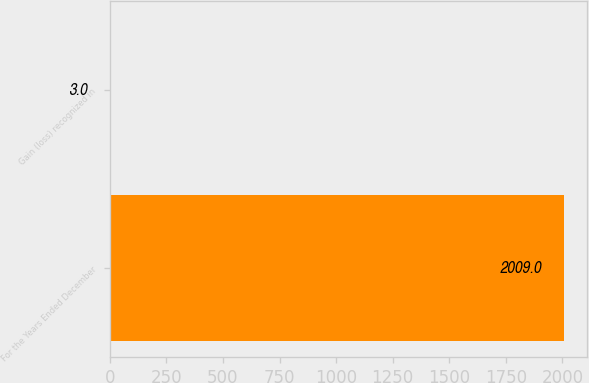Convert chart. <chart><loc_0><loc_0><loc_500><loc_500><bar_chart><fcel>For the Years Ended December<fcel>Gain (loss) recognized in<nl><fcel>2009<fcel>3<nl></chart> 